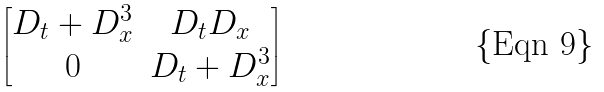Convert formula to latex. <formula><loc_0><loc_0><loc_500><loc_500>\begin{bmatrix} D _ { t } + D _ { x } ^ { 3 } & D _ { t } D _ { x } \\ 0 & D _ { t } + D _ { x } ^ { 3 } \end{bmatrix}</formula> 